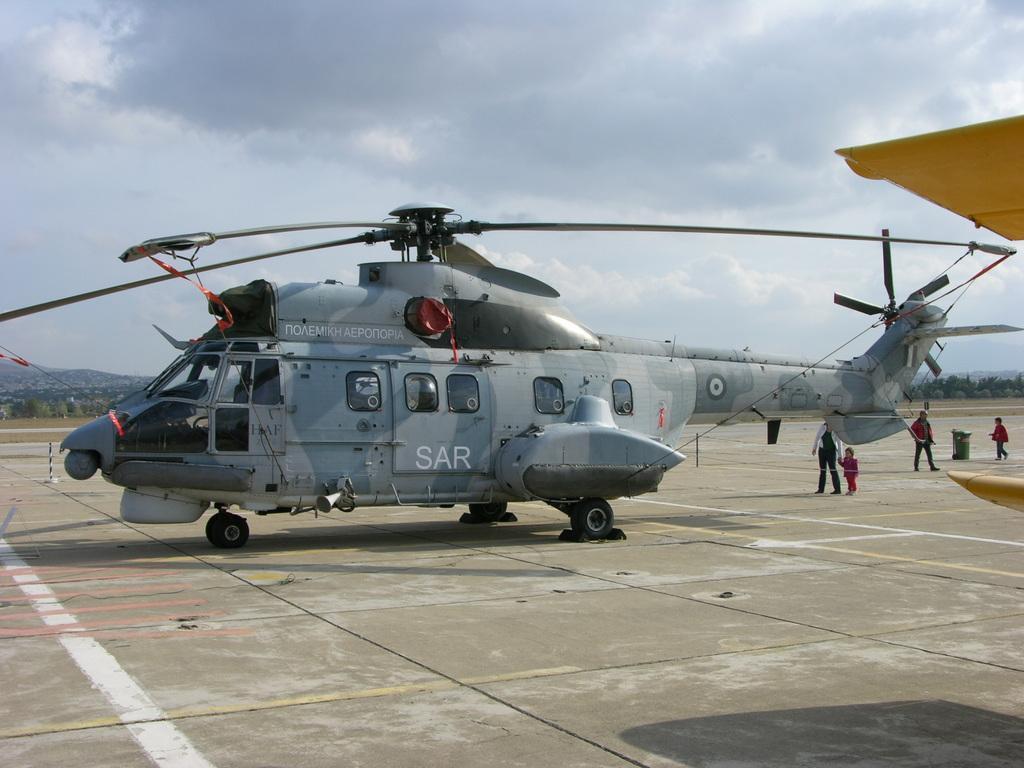Can you describe this image briefly? In this image I can see a helicopter and on it I can see something is written. On the right side of the image I can see two persons and two children are standing. In the background I can see number of trees, clouds and the sky. I can also see two yellow colour things on the right side of the image. 